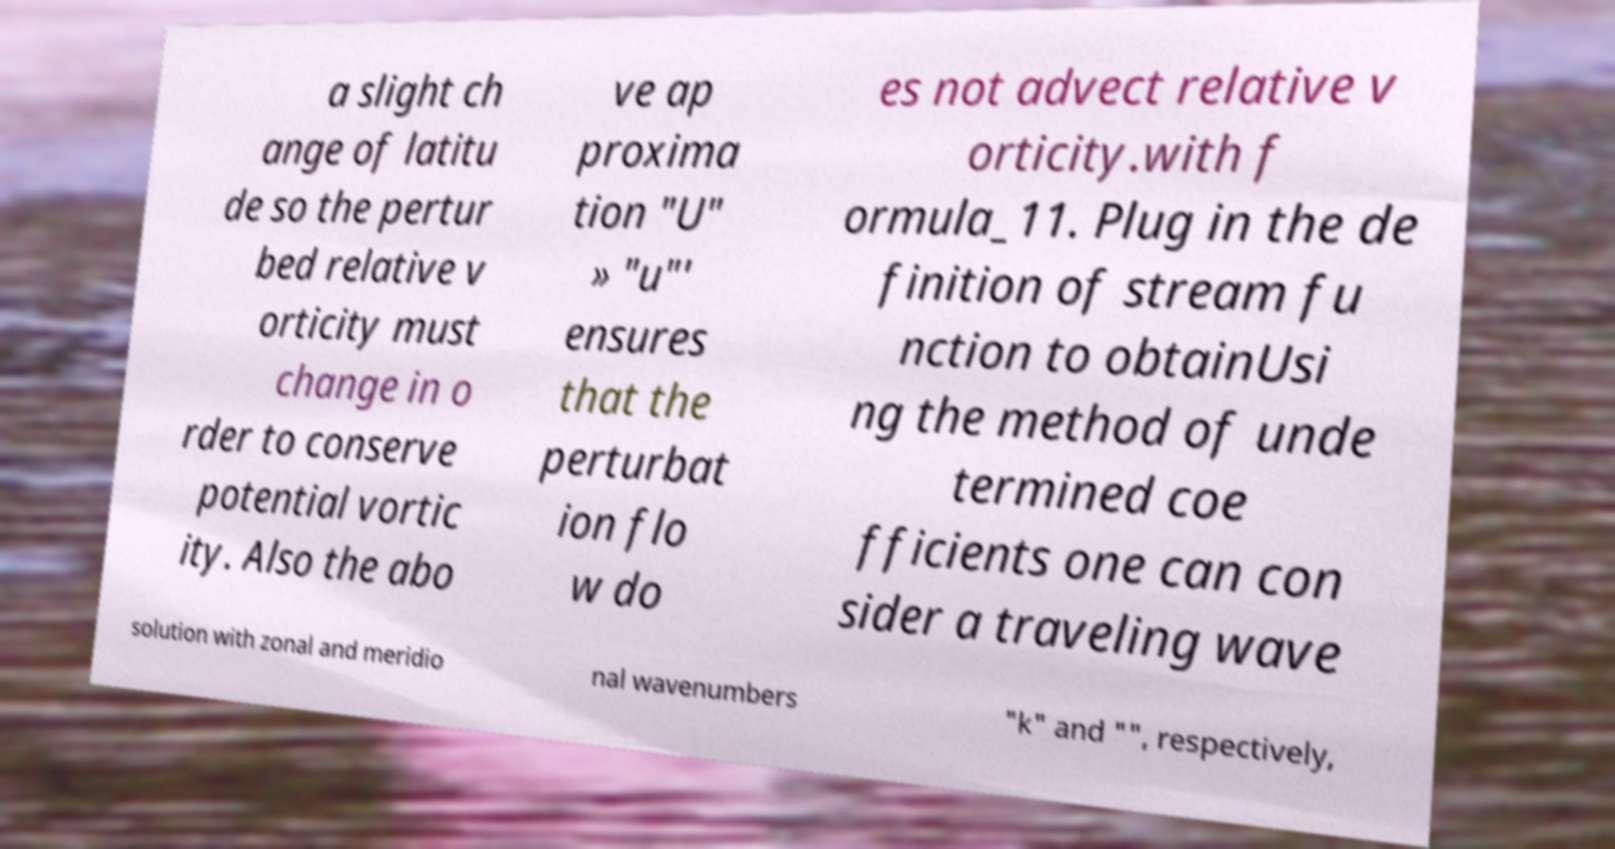Can you accurately transcribe the text from the provided image for me? a slight ch ange of latitu de so the pertur bed relative v orticity must change in o rder to conserve potential vortic ity. Also the abo ve ap proxima tion "U" » "u"' ensures that the perturbat ion flo w do es not advect relative v orticity.with f ormula_11. Plug in the de finition of stream fu nction to obtainUsi ng the method of unde termined coe fficients one can con sider a traveling wave solution with zonal and meridio nal wavenumbers "k" and "", respectively, 